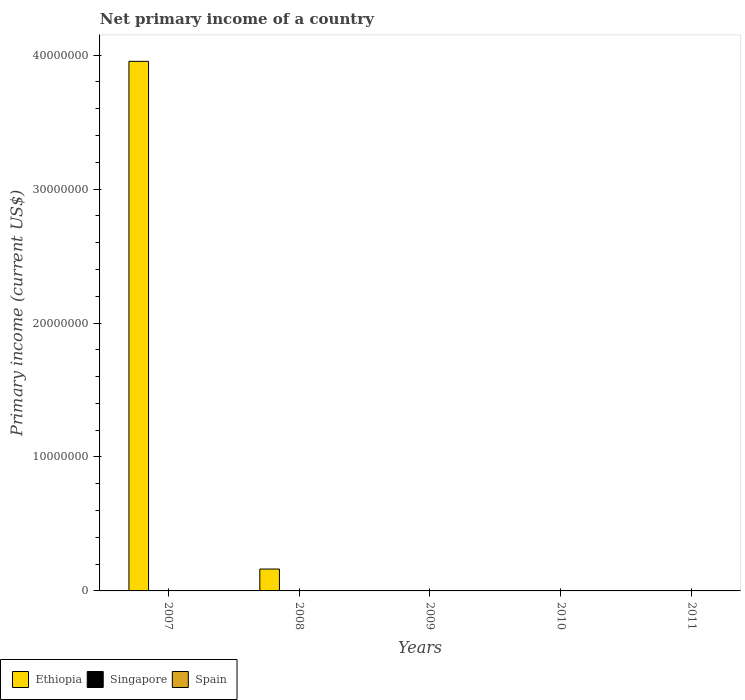How many different coloured bars are there?
Make the answer very short. 1. How many bars are there on the 3rd tick from the left?
Ensure brevity in your answer.  0. How many bars are there on the 5th tick from the right?
Make the answer very short. 1. In how many cases, is the number of bars for a given year not equal to the number of legend labels?
Ensure brevity in your answer.  5. What is the primary income in Spain in 2009?
Your answer should be very brief. 0. Across all years, what is the maximum primary income in Ethiopia?
Offer a terse response. 3.95e+07. What is the total primary income in Spain in the graph?
Keep it short and to the point. 0. What is the difference between the primary income in Ethiopia in 2007 and that in 2008?
Offer a very short reply. 3.79e+07. What is the difference between the highest and the lowest primary income in Ethiopia?
Your response must be concise. 3.95e+07. Is it the case that in every year, the sum of the primary income in Ethiopia and primary income in Spain is greater than the primary income in Singapore?
Your answer should be very brief. No. Are all the bars in the graph horizontal?
Give a very brief answer. No. Does the graph contain any zero values?
Offer a very short reply. Yes. Where does the legend appear in the graph?
Keep it short and to the point. Bottom left. What is the title of the graph?
Offer a very short reply. Net primary income of a country. Does "Sint Maarten (Dutch part)" appear as one of the legend labels in the graph?
Ensure brevity in your answer.  No. What is the label or title of the Y-axis?
Make the answer very short. Primary income (current US$). What is the Primary income (current US$) in Ethiopia in 2007?
Your answer should be very brief. 3.95e+07. What is the Primary income (current US$) of Singapore in 2007?
Offer a very short reply. 0. What is the Primary income (current US$) in Ethiopia in 2008?
Make the answer very short. 1.63e+06. What is the Primary income (current US$) in Singapore in 2008?
Ensure brevity in your answer.  0. What is the Primary income (current US$) in Spain in 2008?
Ensure brevity in your answer.  0. What is the Primary income (current US$) in Ethiopia in 2009?
Your answer should be very brief. 0. What is the Primary income (current US$) of Singapore in 2009?
Keep it short and to the point. 0. What is the Primary income (current US$) in Ethiopia in 2011?
Ensure brevity in your answer.  0. What is the Primary income (current US$) in Singapore in 2011?
Your answer should be compact. 0. What is the Primary income (current US$) of Spain in 2011?
Your response must be concise. 0. Across all years, what is the maximum Primary income (current US$) of Ethiopia?
Give a very brief answer. 3.95e+07. What is the total Primary income (current US$) in Ethiopia in the graph?
Offer a very short reply. 4.12e+07. What is the total Primary income (current US$) in Spain in the graph?
Ensure brevity in your answer.  0. What is the difference between the Primary income (current US$) of Ethiopia in 2007 and that in 2008?
Your answer should be very brief. 3.79e+07. What is the average Primary income (current US$) in Ethiopia per year?
Your answer should be very brief. 8.23e+06. What is the ratio of the Primary income (current US$) of Ethiopia in 2007 to that in 2008?
Your answer should be very brief. 24.19. What is the difference between the highest and the lowest Primary income (current US$) in Ethiopia?
Your response must be concise. 3.95e+07. 